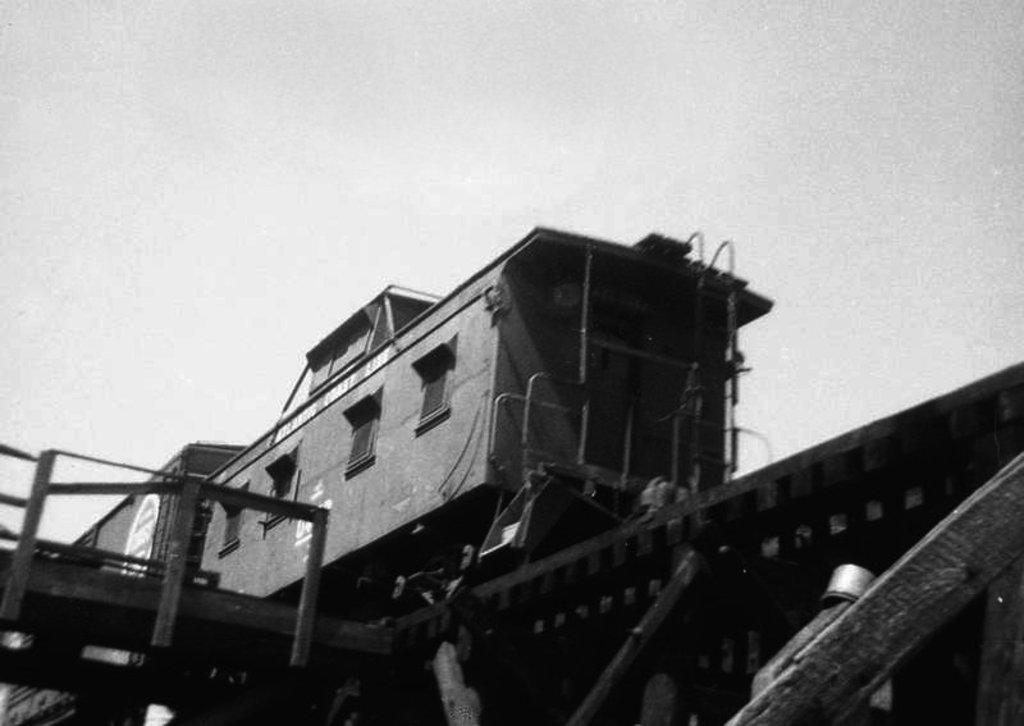How would you summarize this image in a sentence or two? As we can see in the image there is a train, railway track and sky. 